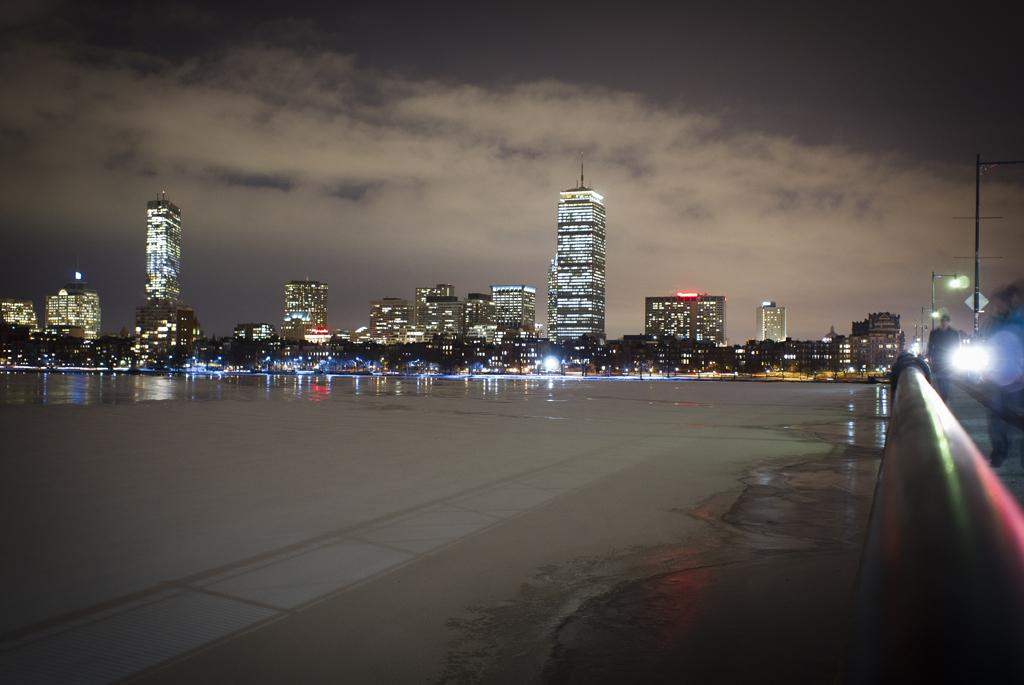What is the primary element visible in the image? There is a water surface in the image. What can be seen on the right side of the image? There is a wall on the right side of the image. What type of structures are visible in the image? There are buildings visible in the image. What is visible in the sky at the top of the image? Clouds are present in the sky at the top of the image. How many spiders can be seen crawling on the wall in the image? There are no spiders visible in the image; the wall is the only element mentioned on the right side of the image. 